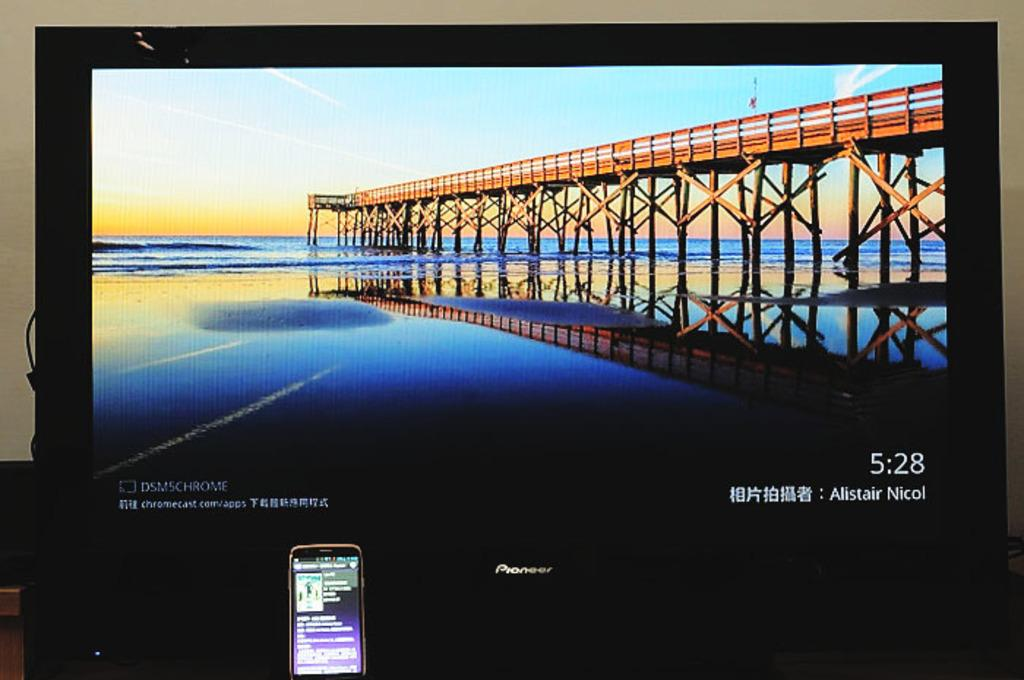<image>
Present a compact description of the photo's key features. A laptop home screen with a bridge on it and time that reads 5:28. 